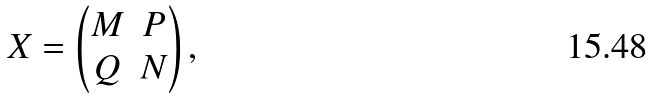<formula> <loc_0><loc_0><loc_500><loc_500>X = \begin{pmatrix} M & P \\ Q & N \end{pmatrix} ,</formula> 